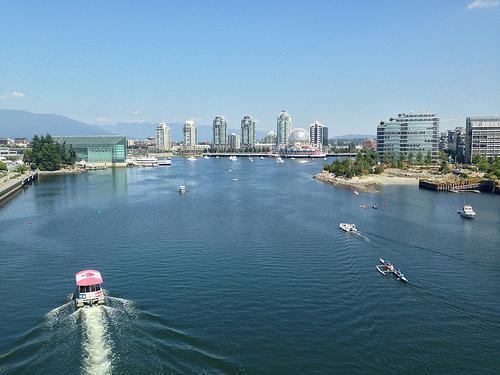How many people are visible?
Give a very brief answer. 0. How many round domes are there?
Give a very brief answer. 1. 